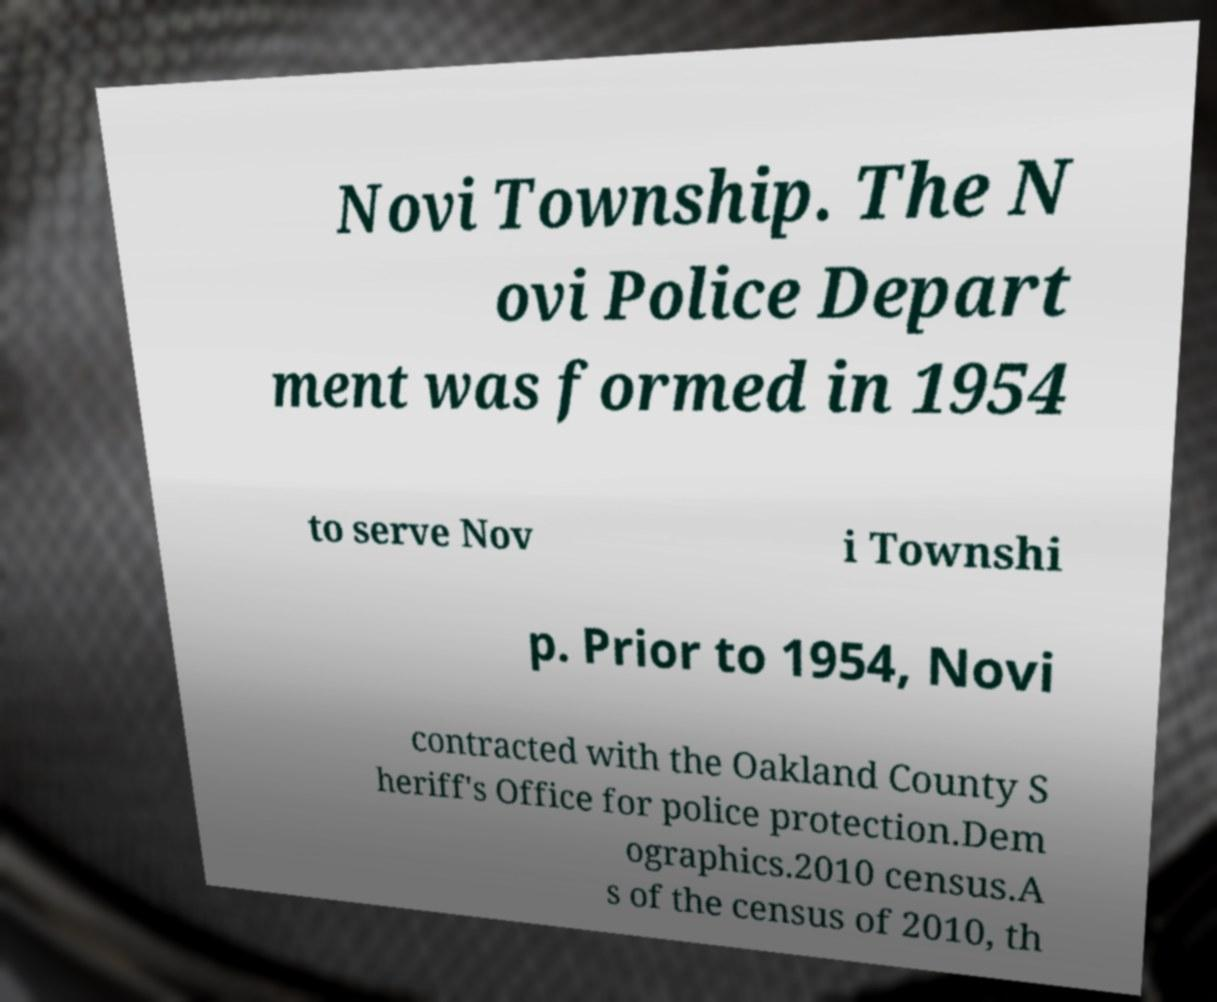Can you read and provide the text displayed in the image?This photo seems to have some interesting text. Can you extract and type it out for me? Novi Township. The N ovi Police Depart ment was formed in 1954 to serve Nov i Townshi p. Prior to 1954, Novi contracted with the Oakland County S heriff's Office for police protection.Dem ographics.2010 census.A s of the census of 2010, th 